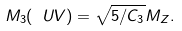Convert formula to latex. <formula><loc_0><loc_0><loc_500><loc_500>M _ { 3 } ( \ U V ) = \sqrt { 5 / C _ { 3 } } M _ { Z } .</formula> 